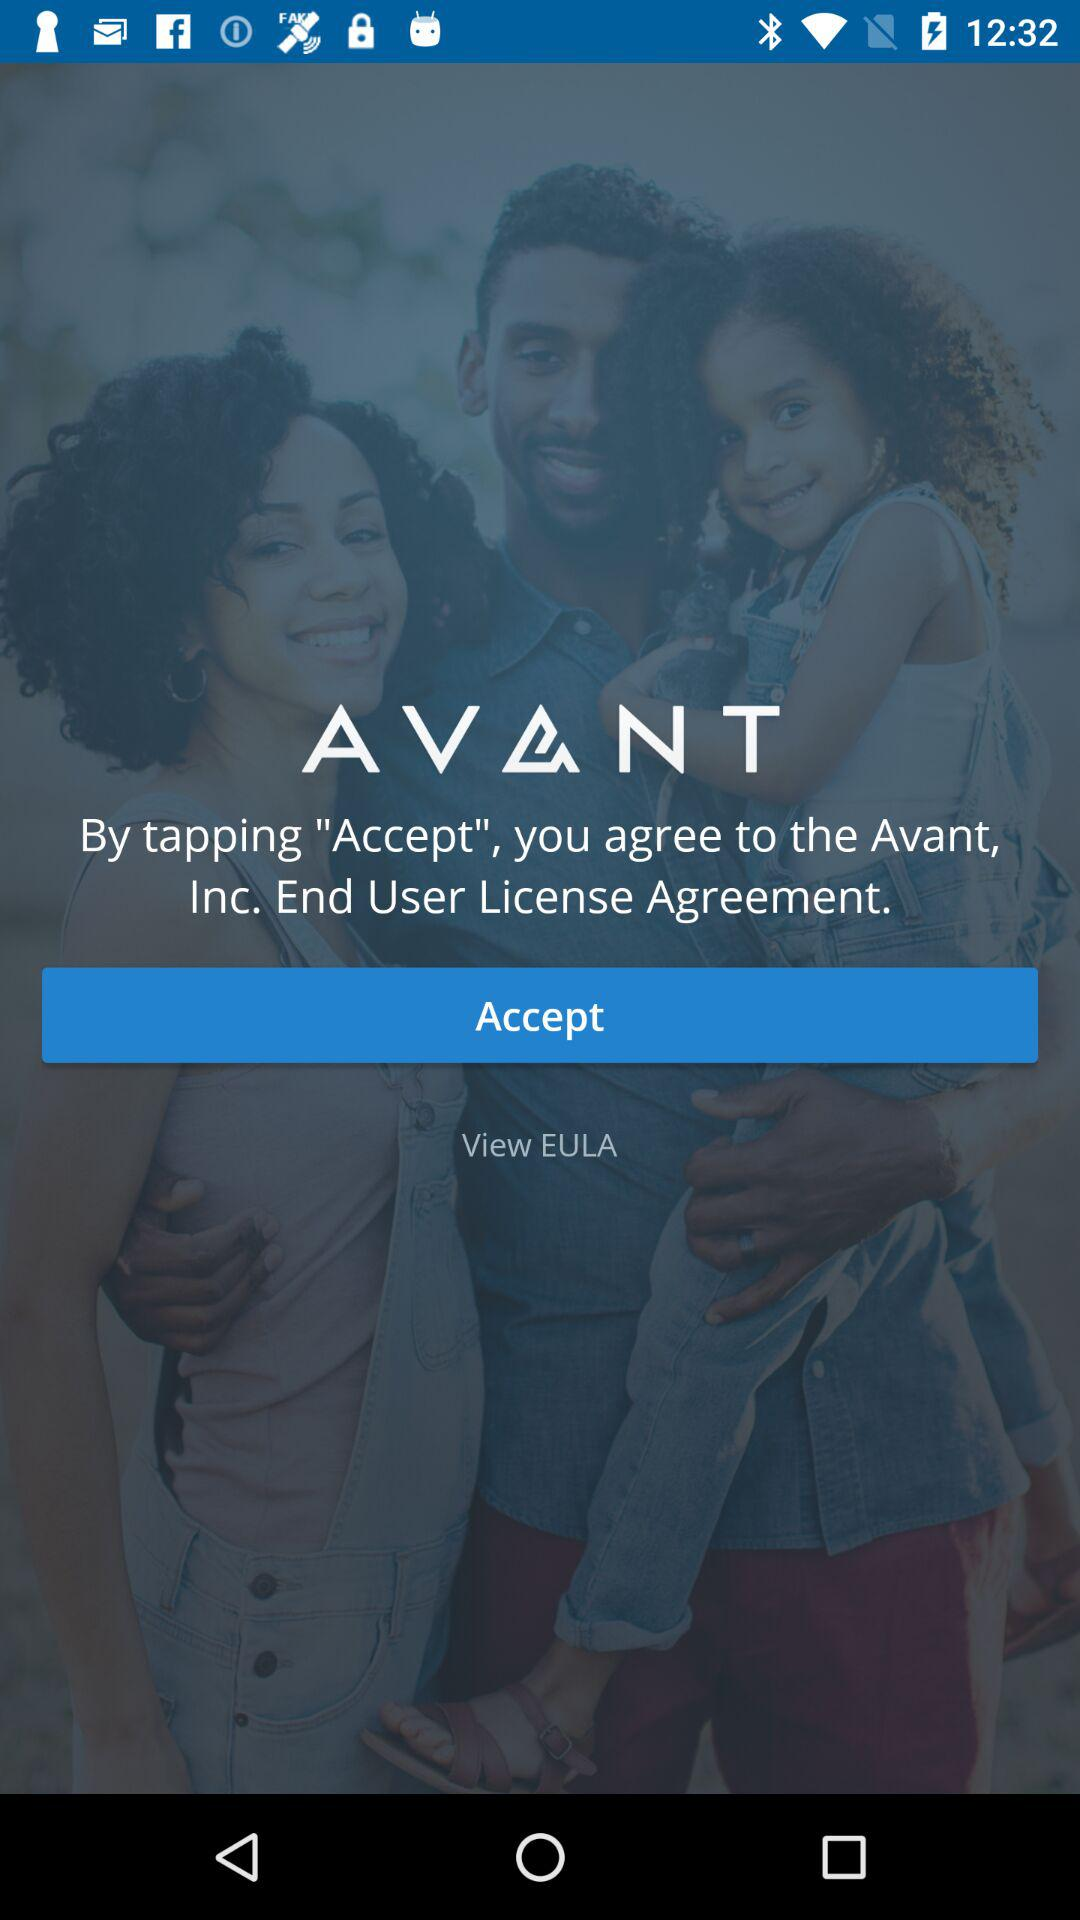What is the full form of the EULA? The full form is End User License Agreement. 